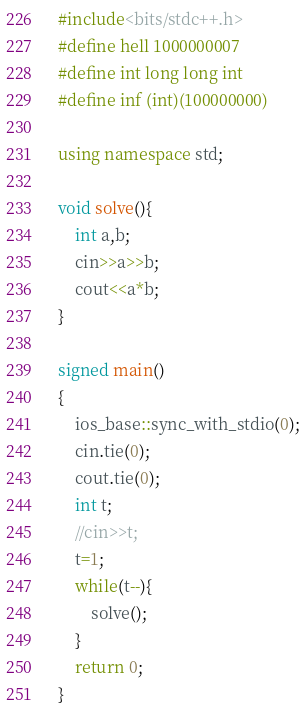<code> <loc_0><loc_0><loc_500><loc_500><_C++_>#include<bits/stdc++.h>
#define hell 1000000007
#define int long long int
#define inf (int)(100000000)

using namespace std;

void solve(){
    int a,b;
    cin>>a>>b;
    cout<<a*b;
}

signed main()
{
    ios_base::sync_with_stdio(0);
    cin.tie(0);
    cout.tie(0);
    int t;
    //cin>>t;
    t=1;
    while(t--){
        solve();
    }
    return 0;
}

</code> 